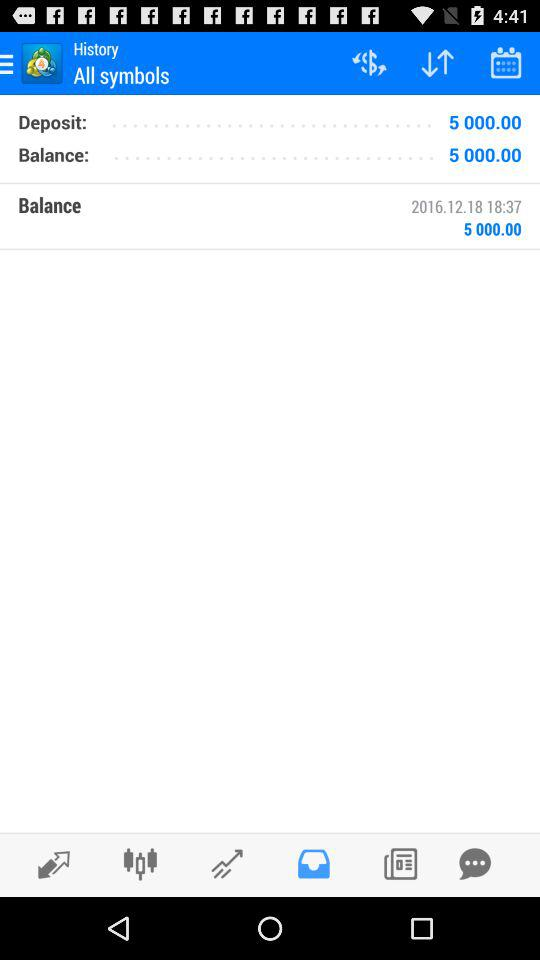How much is the balance? The balance is $5,000. 